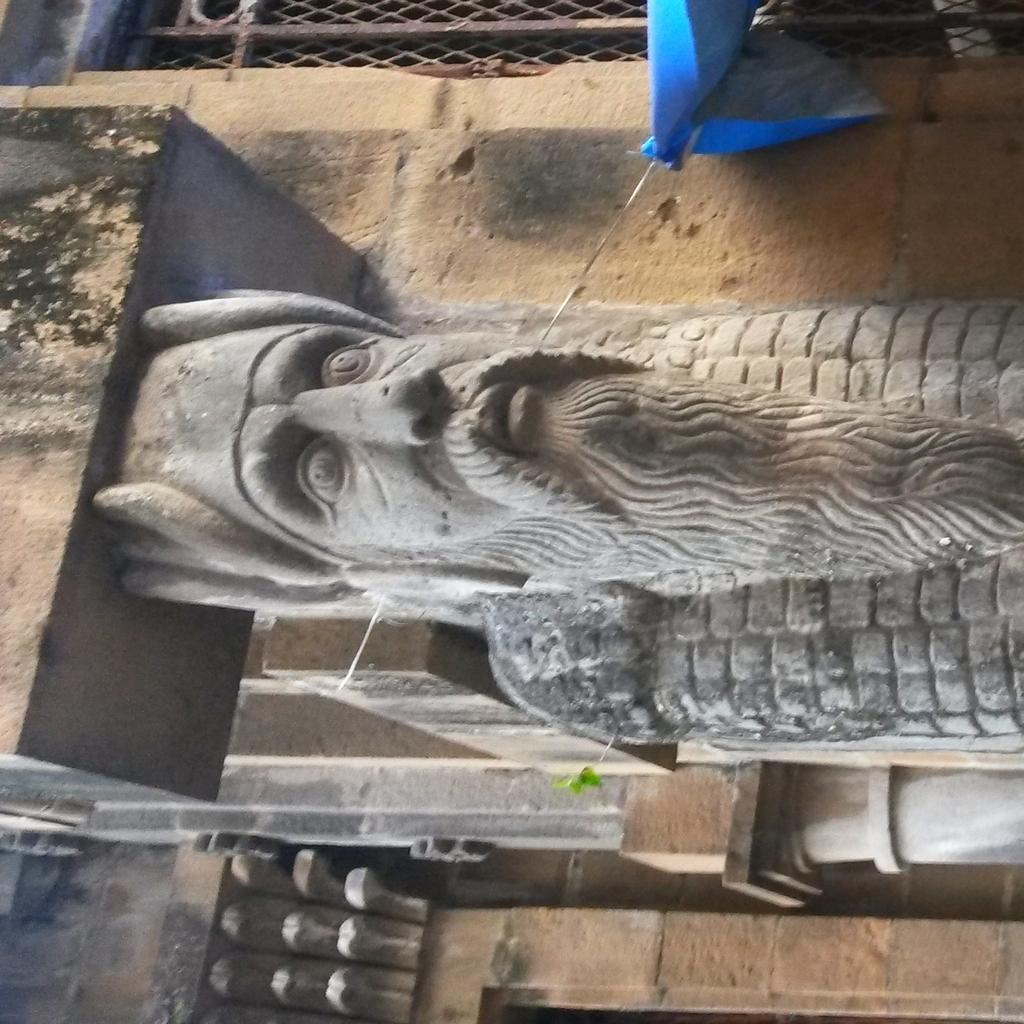What is there is a statue in the center of the image, what is its main feature? The main feature of the statue in the image is its central location. What structure can be seen behind the statue? There is a building behind the statue in the image. What is the purpose of the cover tied to a wire on the right side of the image? The purpose of the cover tied to a wire on the right side of the image is not clear from the provided facts. What type of barrier is present in the image? There is a metal fence in the image. What type of plantation can be seen in the background of the image? There is no plantation present in the image; it features a statue, a building, a cover tied to a wire, and a metal fence. 